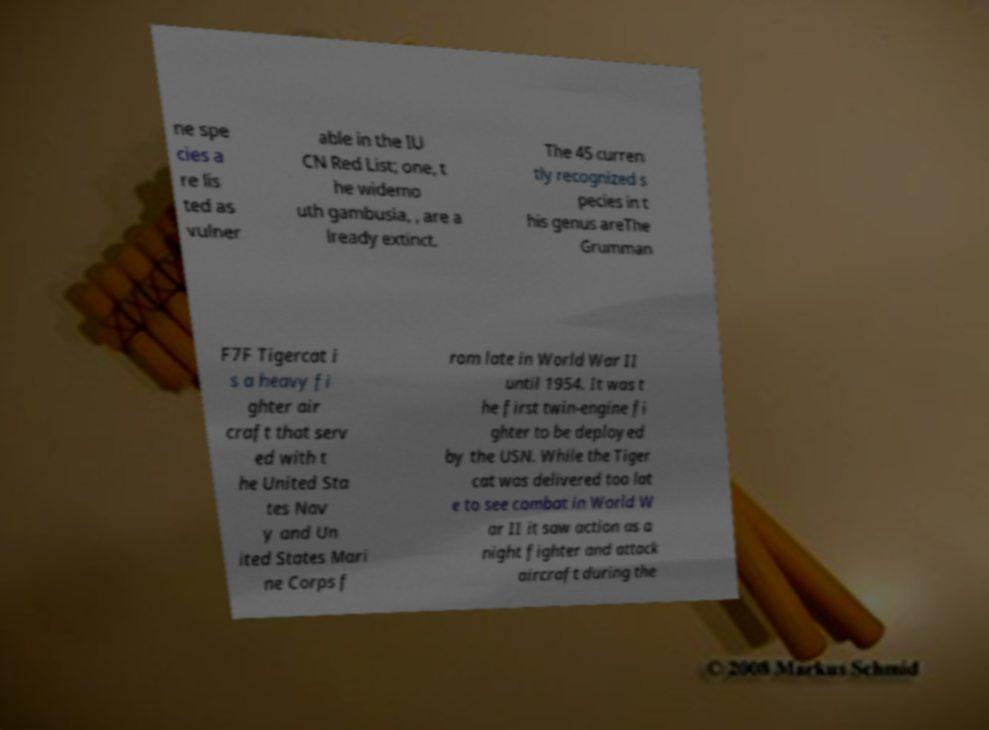What messages or text are displayed in this image? I need them in a readable, typed format. ne spe cies a re lis ted as vulner able in the IU CN Red List; one, t he widemo uth gambusia, , are a lready extinct. The 45 curren tly recognized s pecies in t his genus areThe Grumman F7F Tigercat i s a heavy fi ghter air craft that serv ed with t he United Sta tes Nav y and Un ited States Mari ne Corps f rom late in World War II until 1954. It was t he first twin-engine fi ghter to be deployed by the USN. While the Tiger cat was delivered too lat e to see combat in World W ar II it saw action as a night fighter and attack aircraft during the 